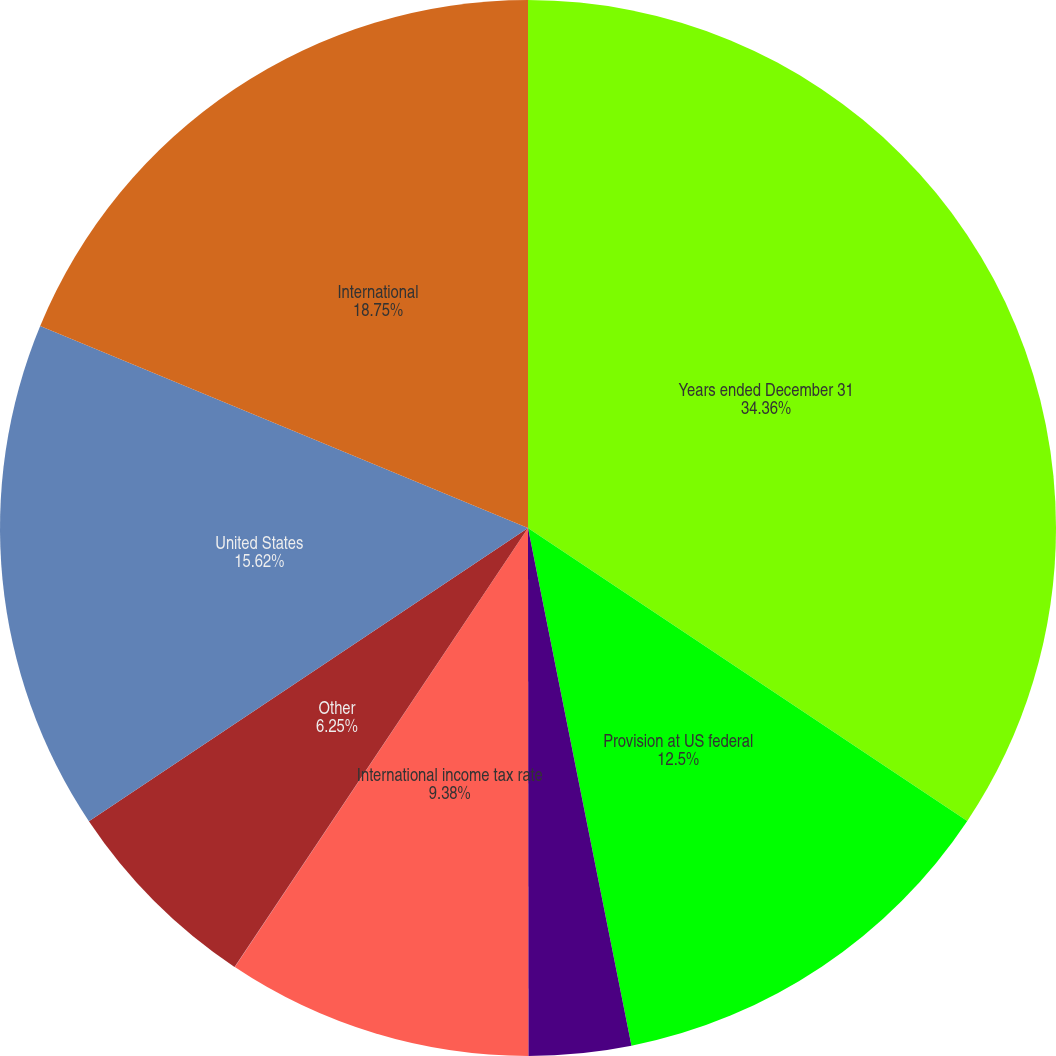<chart> <loc_0><loc_0><loc_500><loc_500><pie_chart><fcel>Years ended December 31<fcel>Provision at US federal<fcel>State income and franchise<fcel>International income tax rate<fcel>Research tax credits<fcel>Other<fcel>United States<fcel>International<nl><fcel>34.36%<fcel>12.5%<fcel>3.13%<fcel>9.38%<fcel>0.01%<fcel>6.25%<fcel>15.62%<fcel>18.75%<nl></chart> 